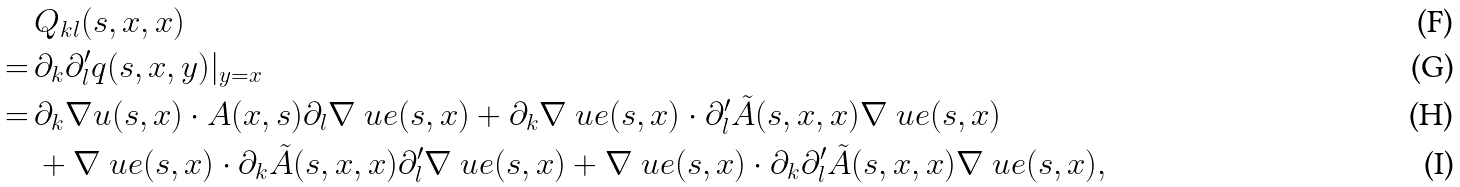<formula> <loc_0><loc_0><loc_500><loc_500>& Q _ { k l } ( s , x , x ) \\ = \, & \partial _ { k } \partial _ { l } ^ { \prime } q ( s , x , y ) | _ { y = x } \\ = \, & \partial _ { k } \nabla u ( s , x ) \cdot A ( x , s ) \partial _ { l } \nabla \ u e ( s , x ) + \partial _ { k } \nabla \ u e ( s , x ) \cdot \partial _ { l } ^ { \prime } \tilde { A } ( s , x , x ) \nabla \ u e ( s , x ) \\ & + \nabla \ u e ( s , x ) \cdot \partial _ { k } \tilde { A } ( s , x , x ) \partial _ { l } ^ { \prime } \nabla \ u e ( s , x ) + \nabla \ u e ( s , x ) \cdot \partial _ { k } \partial _ { l } ^ { \prime } \tilde { A } ( s , x , x ) \nabla \ u e ( s , x ) ,</formula> 